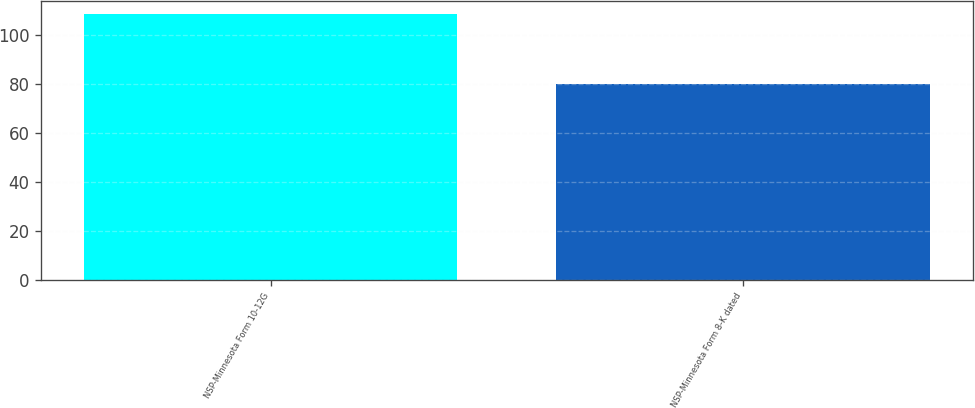Convert chart. <chart><loc_0><loc_0><loc_500><loc_500><bar_chart><fcel>NSP-Minnesota Form 10-12G<fcel>NSP-Minnesota Form 8-K dated<nl><fcel>108.51<fcel>80.01<nl></chart> 